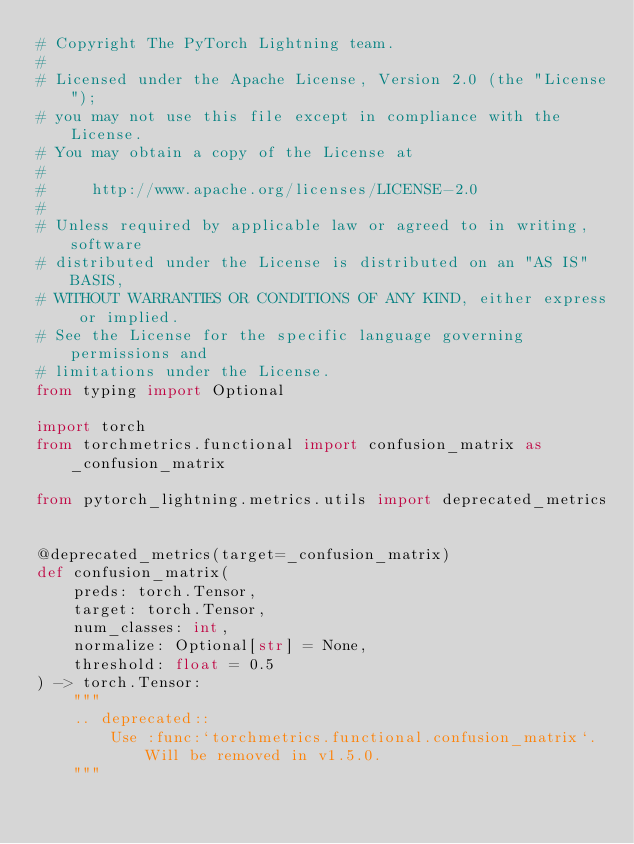<code> <loc_0><loc_0><loc_500><loc_500><_Python_># Copyright The PyTorch Lightning team.
#
# Licensed under the Apache License, Version 2.0 (the "License");
# you may not use this file except in compliance with the License.
# You may obtain a copy of the License at
#
#     http://www.apache.org/licenses/LICENSE-2.0
#
# Unless required by applicable law or agreed to in writing, software
# distributed under the License is distributed on an "AS IS" BASIS,
# WITHOUT WARRANTIES OR CONDITIONS OF ANY KIND, either express or implied.
# See the License for the specific language governing permissions and
# limitations under the License.
from typing import Optional

import torch
from torchmetrics.functional import confusion_matrix as _confusion_matrix

from pytorch_lightning.metrics.utils import deprecated_metrics


@deprecated_metrics(target=_confusion_matrix)
def confusion_matrix(
    preds: torch.Tensor,
    target: torch.Tensor,
    num_classes: int,
    normalize: Optional[str] = None,
    threshold: float = 0.5
) -> torch.Tensor:
    """
    .. deprecated::
        Use :func:`torchmetrics.functional.confusion_matrix`. Will be removed in v1.5.0.
    """
</code> 